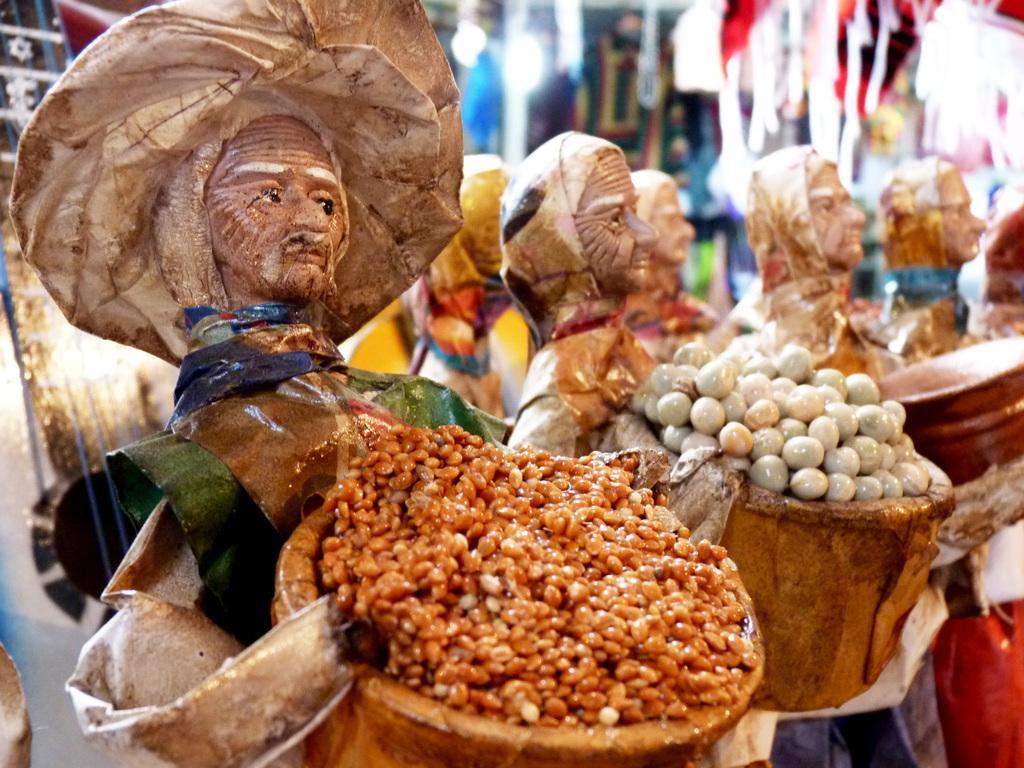How would you summarize this image in a sentence or two? In this image, we can see some toys holding a basket in their hands with some food. 